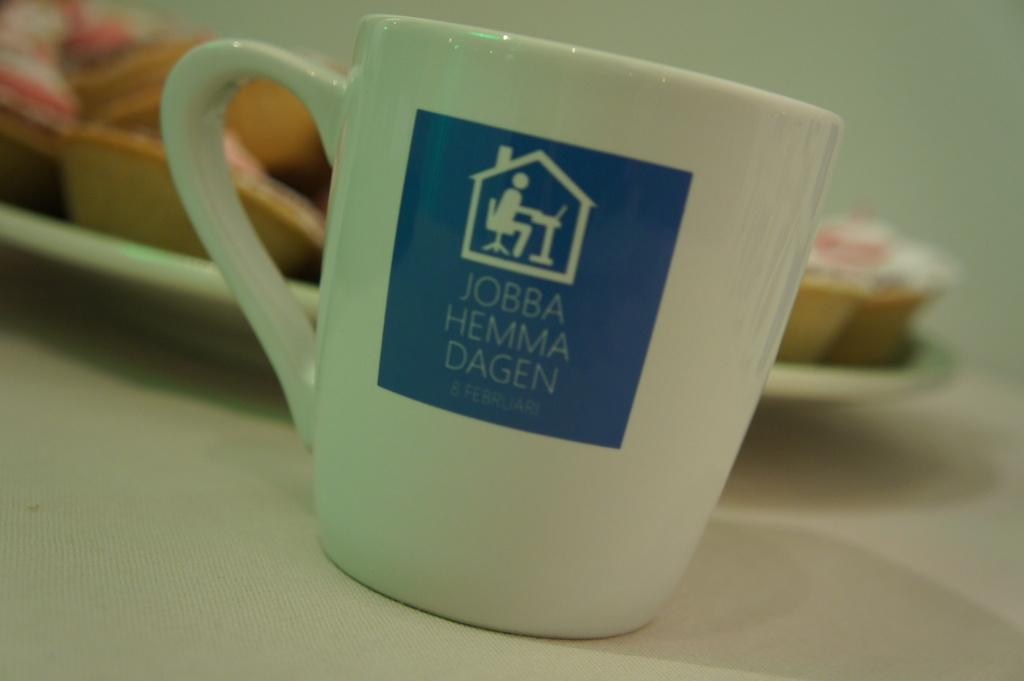What is on this mug?
Provide a short and direct response. Jobba hemma dagen. What month is mentioned on the mug?
Offer a terse response. February. 